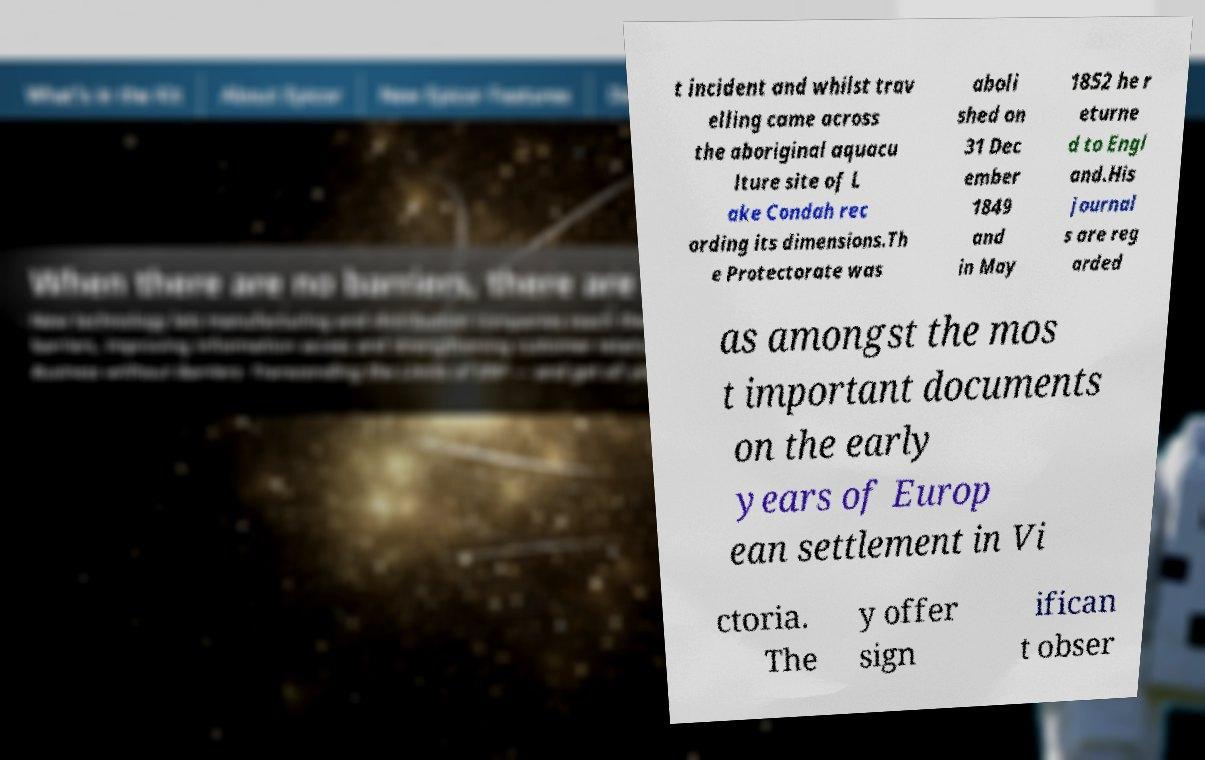Can you read and provide the text displayed in the image?This photo seems to have some interesting text. Can you extract and type it out for me? t incident and whilst trav elling came across the aboriginal aquacu lture site of L ake Condah rec ording its dimensions.Th e Protectorate was aboli shed on 31 Dec ember 1849 and in May 1852 he r eturne d to Engl and.His journal s are reg arded as amongst the mos t important documents on the early years of Europ ean settlement in Vi ctoria. The y offer sign ifican t obser 